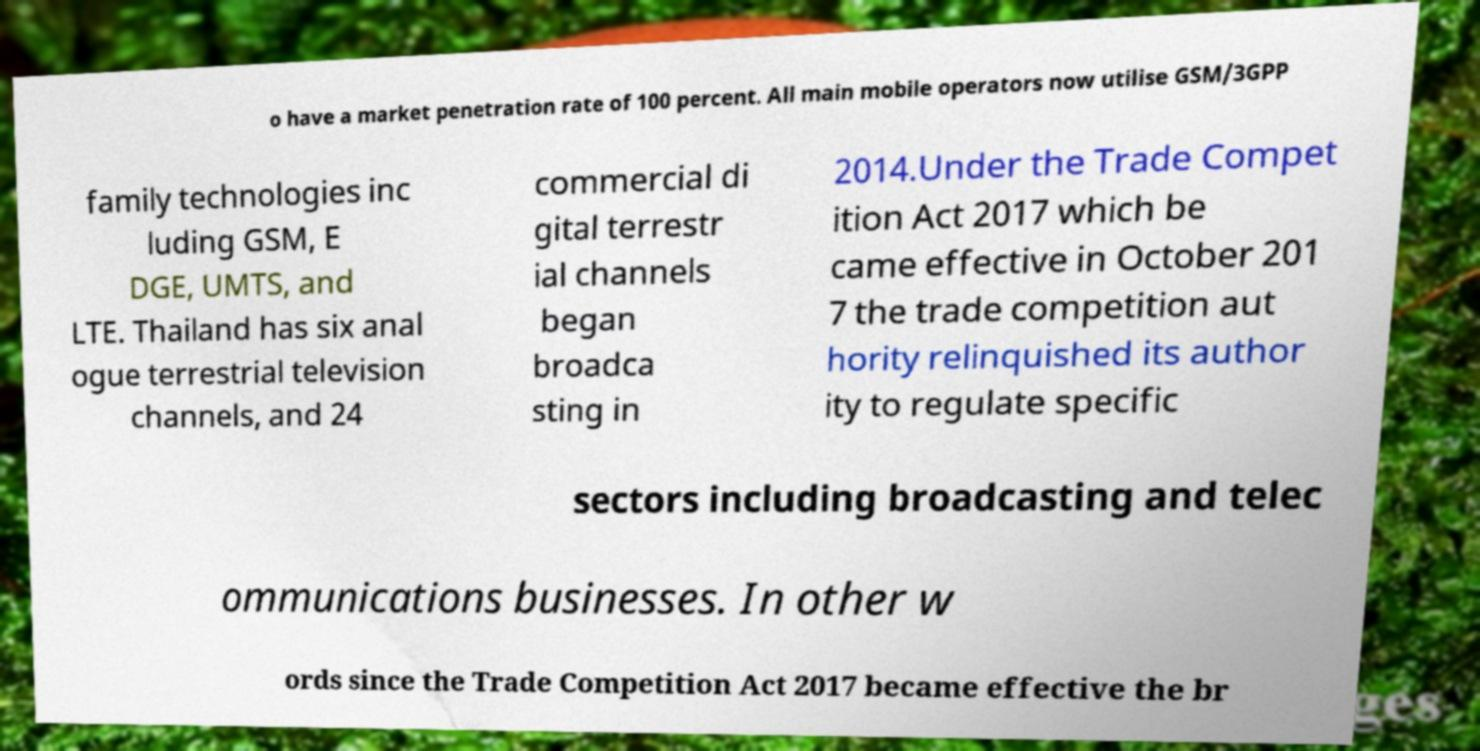For documentation purposes, I need the text within this image transcribed. Could you provide that? o have a market penetration rate of 100 percent. All main mobile operators now utilise GSM/3GPP family technologies inc luding GSM, E DGE, UMTS, and LTE. Thailand has six anal ogue terrestrial television channels, and 24 commercial di gital terrestr ial channels began broadca sting in 2014.Under the Trade Compet ition Act 2017 which be came effective in October 201 7 the trade competition aut hority relinquished its author ity to regulate specific sectors including broadcasting and telec ommunications businesses. In other w ords since the Trade Competition Act 2017 became effective the br 